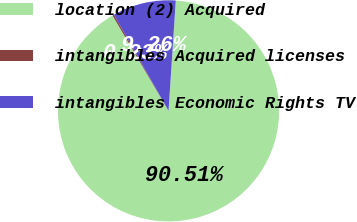<chart> <loc_0><loc_0><loc_500><loc_500><pie_chart><fcel>location (2) Acquired<fcel>intangibles Acquired licenses<fcel>intangibles Economic Rights TV<nl><fcel>90.51%<fcel>0.23%<fcel>9.26%<nl></chart> 